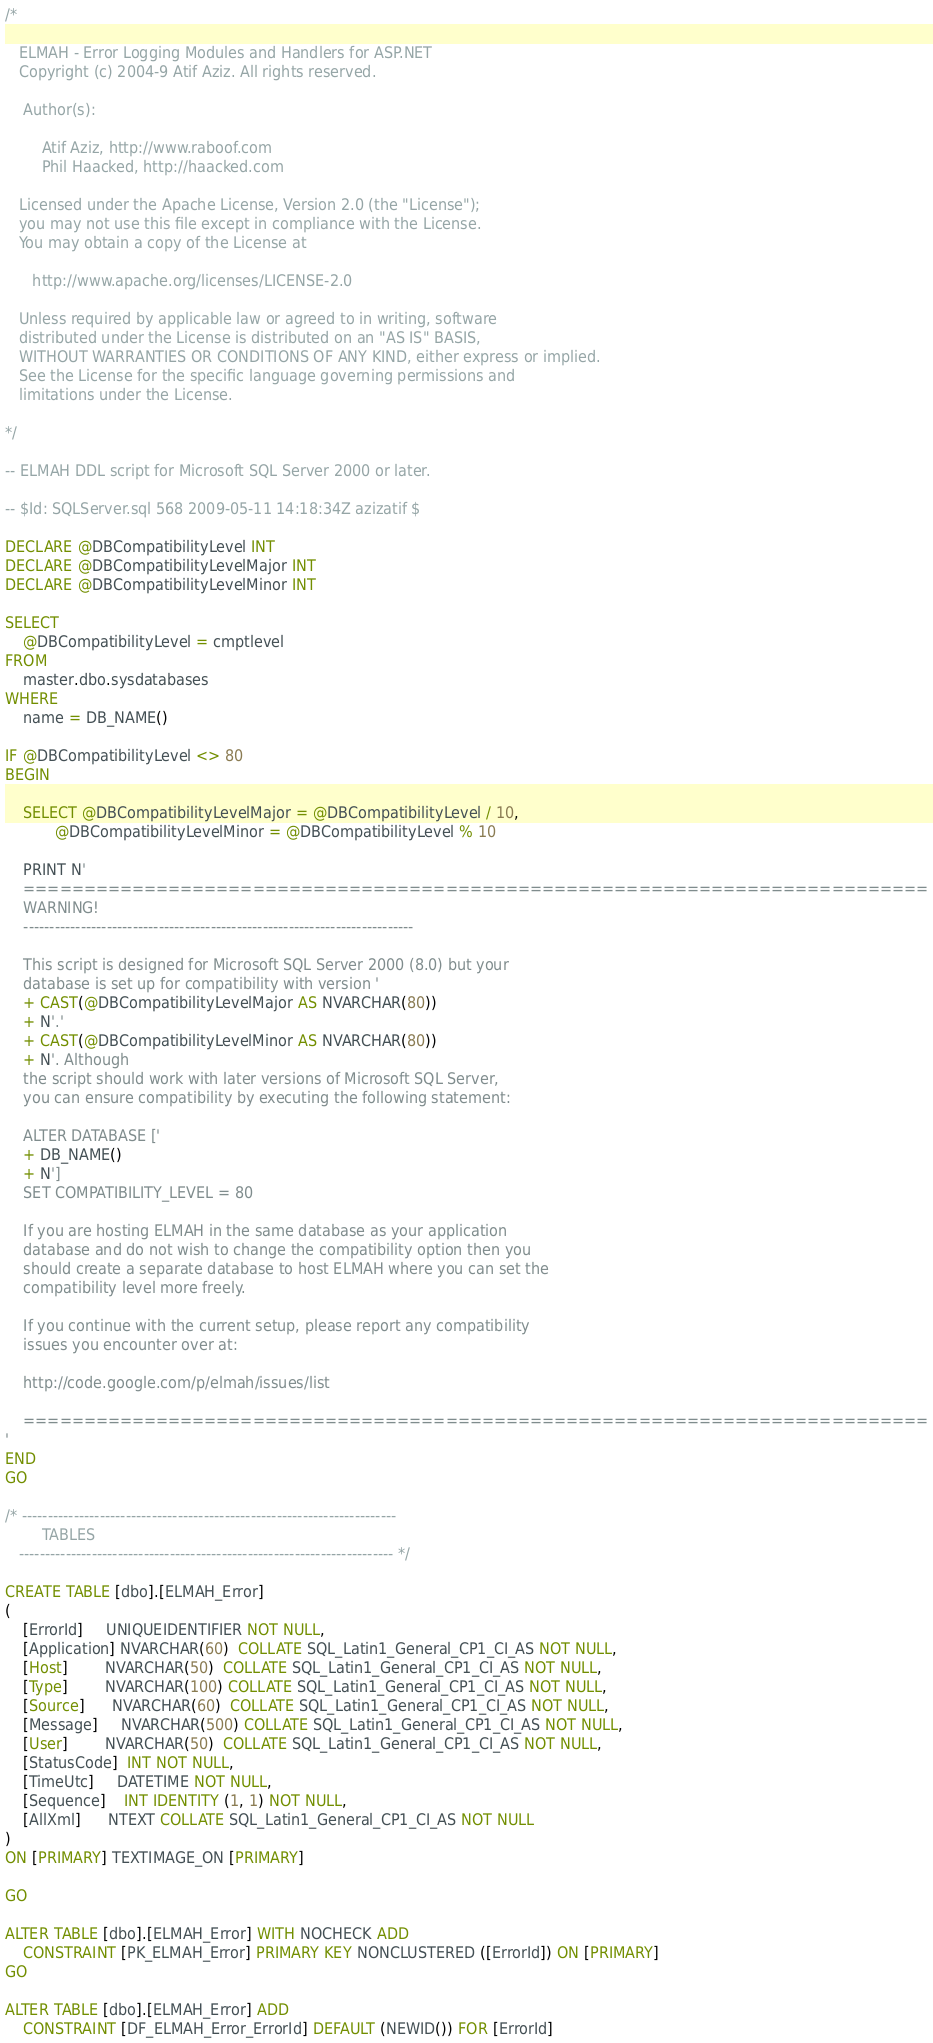Convert code to text. <code><loc_0><loc_0><loc_500><loc_500><_SQL_>/*
  
   ELMAH - Error Logging Modules and Handlers for ASP.NET
   Copyright (c) 2004-9 Atif Aziz. All rights reserved.
  
    Author(s):
  
        Atif Aziz, http://www.raboof.com
        Phil Haacked, http://haacked.com
  
   Licensed under the Apache License, Version 2.0 (the "License");
   you may not use this file except in compliance with the License.
   You may obtain a copy of the License at
  
      http://www.apache.org/licenses/LICENSE-2.0
  
   Unless required by applicable law or agreed to in writing, software
   distributed under the License is distributed on an "AS IS" BASIS,
   WITHOUT WARRANTIES OR CONDITIONS OF ANY KIND, either express or implied.
   See the License for the specific language governing permissions and
   limitations under the License.
  
*/

-- ELMAH DDL script for Microsoft SQL Server 2000 or later.

-- $Id: SQLServer.sql 568 2009-05-11 14:18:34Z azizatif $

DECLARE @DBCompatibilityLevel INT
DECLARE @DBCompatibilityLevelMajor INT
DECLARE @DBCompatibilityLevelMinor INT

SELECT 
    @DBCompatibilityLevel = cmptlevel 
FROM 
    master.dbo.sysdatabases 
WHERE 
    name = DB_NAME()

IF @DBCompatibilityLevel <> 80
BEGIN

    SELECT @DBCompatibilityLevelMajor = @DBCompatibilityLevel / 10, 
           @DBCompatibilityLevelMinor = @DBCompatibilityLevel % 10
           
    PRINT N'
    ===========================================================================
    WARNING! 
    ---------------------------------------------------------------------------
    
    This script is designed for Microsoft SQL Server 2000 (8.0) but your 
    database is set up for compatibility with version ' 
    + CAST(@DBCompatibilityLevelMajor AS NVARCHAR(80)) 
    + N'.' 
    + CAST(@DBCompatibilityLevelMinor AS NVARCHAR(80)) 
    + N'. Although 
    the script should work with later versions of Microsoft SQL Server, 
    you can ensure compatibility by executing the following statement:
    
    ALTER DATABASE [' 
    + DB_NAME() 
    + N'] 
    SET COMPATIBILITY_LEVEL = 80

    If you are hosting ELMAH in the same database as your application 
    database and do not wish to change the compatibility option then you 
    should create a separate database to host ELMAH where you can set the 
    compatibility level more freely.
    
    If you continue with the current setup, please report any compatibility 
    issues you encounter over at:
    
    http://code.google.com/p/elmah/issues/list

    ===========================================================================
'
END
GO

/* ------------------------------------------------------------------------ 
        TABLES
   ------------------------------------------------------------------------ */

CREATE TABLE [dbo].[ELMAH_Error]
(
    [ErrorId]     UNIQUEIDENTIFIER NOT NULL,
    [Application] NVARCHAR(60)  COLLATE SQL_Latin1_General_CP1_CI_AS NOT NULL,
    [Host]        NVARCHAR(50)  COLLATE SQL_Latin1_General_CP1_CI_AS NOT NULL,
    [Type]        NVARCHAR(100) COLLATE SQL_Latin1_General_CP1_CI_AS NOT NULL,
    [Source]      NVARCHAR(60)  COLLATE SQL_Latin1_General_CP1_CI_AS NOT NULL,
    [Message]     NVARCHAR(500) COLLATE SQL_Latin1_General_CP1_CI_AS NOT NULL,
    [User]        NVARCHAR(50)  COLLATE SQL_Latin1_General_CP1_CI_AS NOT NULL,
    [StatusCode]  INT NOT NULL,
    [TimeUtc]     DATETIME NOT NULL,
    [Sequence]    INT IDENTITY (1, 1) NOT NULL,
    [AllXml]      NTEXT COLLATE SQL_Latin1_General_CP1_CI_AS NOT NULL 
) 
ON [PRIMARY] TEXTIMAGE_ON [PRIMARY]

GO

ALTER TABLE [dbo].[ELMAH_Error] WITH NOCHECK ADD 
    CONSTRAINT [PK_ELMAH_Error] PRIMARY KEY NONCLUSTERED ([ErrorId]) ON [PRIMARY] 
GO

ALTER TABLE [dbo].[ELMAH_Error] ADD 
    CONSTRAINT [DF_ELMAH_Error_ErrorId] DEFAULT (NEWID()) FOR [ErrorId]</code> 